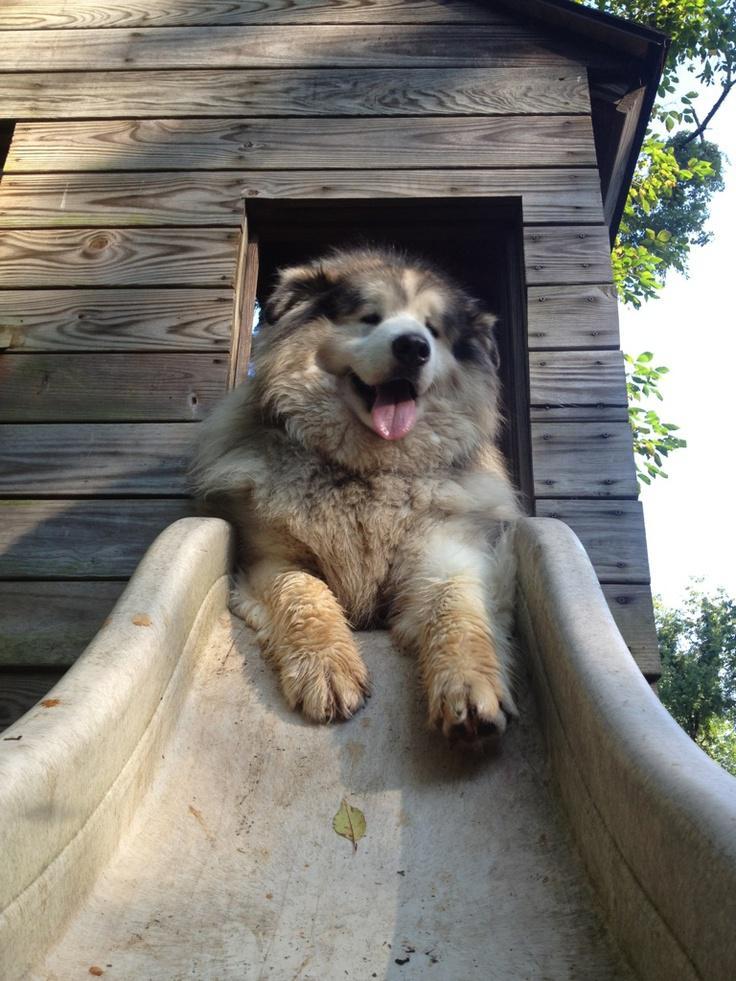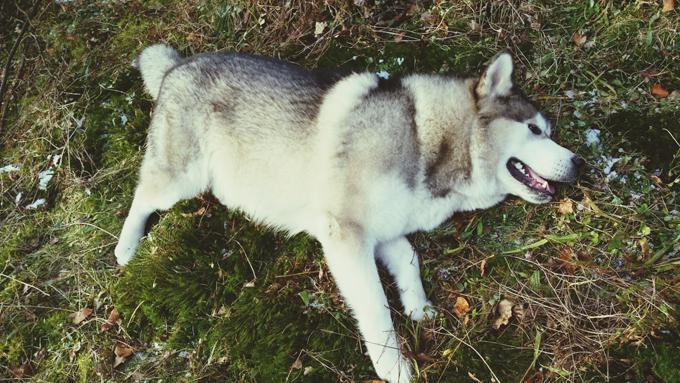The first image is the image on the left, the second image is the image on the right. For the images displayed, is the sentence "Each image contains one dog, and one of the dogs depicted is a husky standing in profile on grass, with white around its eyes and its tail curled inward." factually correct? Answer yes or no. No. 